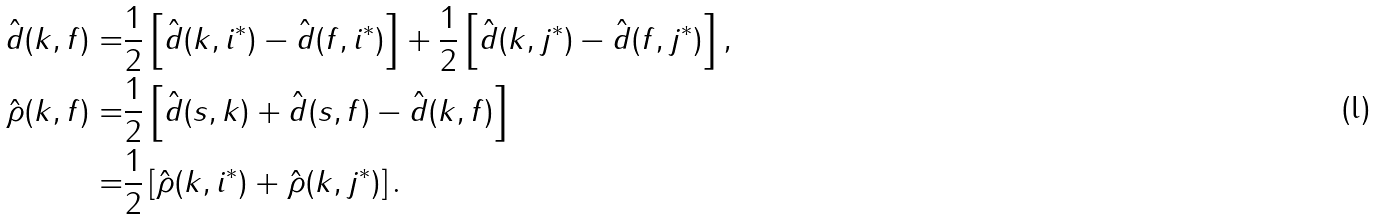Convert formula to latex. <formula><loc_0><loc_0><loc_500><loc_500>\hat { d } ( k , f ) = & \frac { 1 } { 2 } \left [ \hat { d } ( k , i ^ { * } ) - \hat { d } ( f , i ^ { * } ) \right ] + \frac { 1 } { 2 } \left [ \hat { d } ( k , j ^ { * } ) - \hat { d } ( f , j ^ { * } ) \right ] , \\ \hat { \rho } ( k , f ) = & \frac { 1 } { 2 } \left [ \hat { d } ( s , k ) + \hat { d } ( s , f ) - \hat { d } ( k , f ) \right ] \\ = & \frac { 1 } { 2 } \left [ \hat { \rho } ( k , i ^ { * } ) + \hat { \rho } ( k , j ^ { * } ) \right ] .</formula> 